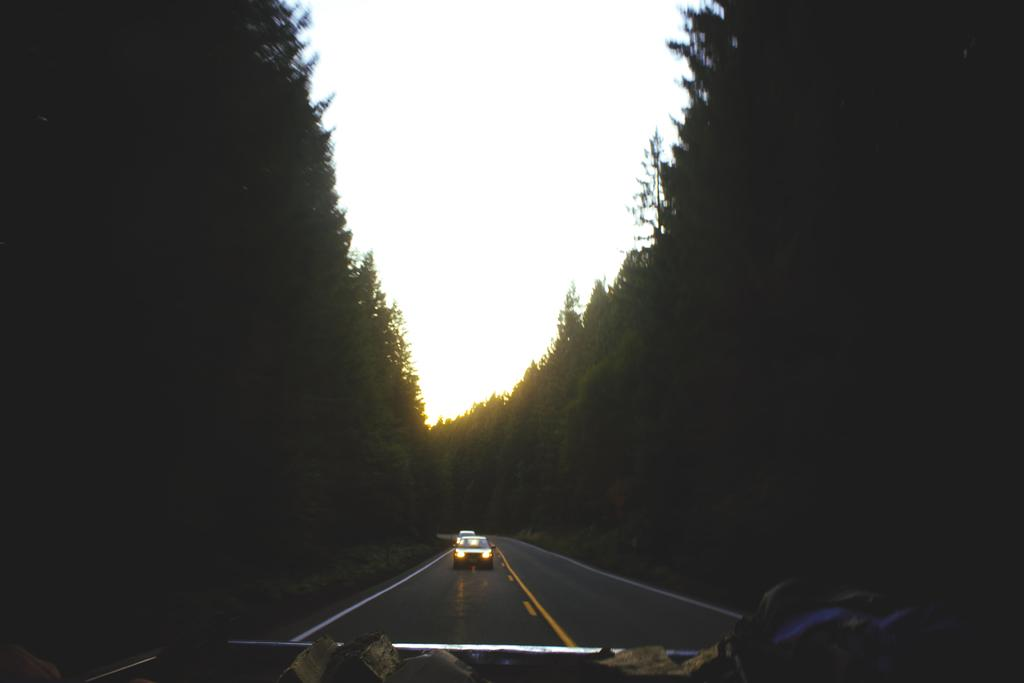What is the main subject of the image? The main subject of the image is a car on the road. Where is the car located in relation to the trees? The car is between trees in the image. What is visible at the top of the image? The sky is visible at the top of the image. What type of hospital can be seen in the background of the image? There is no hospital present in the image; it features a car on the road between trees. What holiday is being celebrated in the image? There is no indication of a holiday being celebrated in the image. 